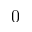<formula> <loc_0><loc_0><loc_500><loc_500>0</formula> 